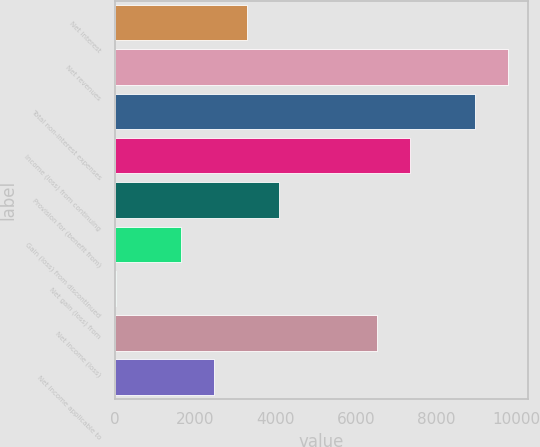<chart> <loc_0><loc_0><loc_500><loc_500><bar_chart><fcel>Net interest<fcel>Net revenues<fcel>Total non-interest expenses<fcel>Income (loss) from continuing<fcel>Provision for (benefit from)<fcel>Gain (loss) from discontinued<fcel>Net gain (loss) from<fcel>Net income (loss)<fcel>Net income applicable to<nl><fcel>3273<fcel>9781<fcel>8967.5<fcel>7340.5<fcel>4086.5<fcel>1646<fcel>19<fcel>6527<fcel>2459.5<nl></chart> 